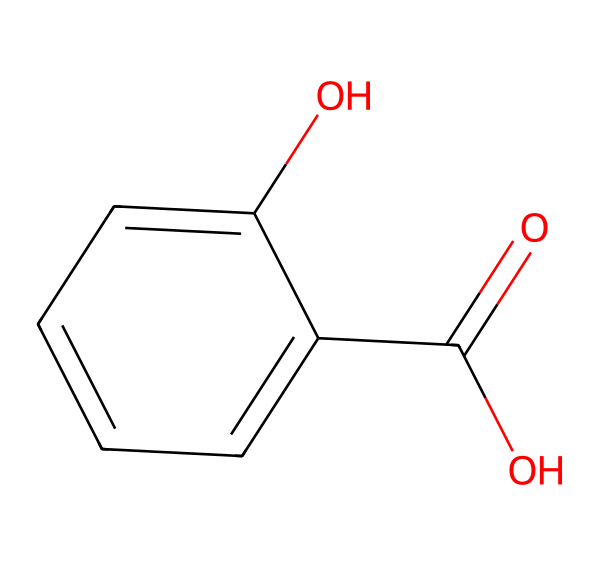What is the molecular formula of salicylic acid? By analyzing the structure of the chemical, we can count the atoms: there are 7 carbon (C) atoms, 6 hydrogen (H) atoms, and 3 oxygen (O) atoms, which gives us the molecular formula C7H6O3.
Answer: C7H6O3 How many hydroxyl groups are present in salicylic acid? In the chemical structure, we can see that there is one hydroxyl group (-OH) attached to the aromatic ring, in addition to the carboxylic acid functional group. Therefore, salicylic acid contains one hydroxyl group.
Answer: one What type of functional group does salicylic acid have? The presence of the -COOH group in the structure indicates a carboxylic acid functional group. In chemical terms, salicylic acid has both a carboxylic acid and an alcohol functional group due to the presence of the -OH group. The predominant functional group is carboxylic acid.
Answer: carboxylic acid Which property allows salicylic acid to act as a precursor to aspirin? The presence of the hydroxyl group (-OH) and the carboxylic acid group (-COOH) make salicylic acid a suitable candidate for esterification, which is the reaction required to form aspirin (acetylsalicylic acid). The acetyl group replaces the hydroxyl group in salicylic acid, enabling the conversion to aspirin.
Answer: esterification How does the structure of salicylic acid contribute to its aromatic nature? The structure includes a benzene ring (the six-membered carbon ring) with alternating double bonds, characteristic of aromatic compounds. The stability and resonance that are delivered by this structure are indicative of its aromatic nature.
Answer: benzene ring What distinguishes salicylic acid from aliphatic compounds? Aliphatic compounds lack a benzene ring structure. The presence of the aromatic benzene ring in salicylic acid, with its unique electron delocalization, distinguishes it from aliphatic compounds, which have straight or branched chain configurations.
Answer: benzene ring 